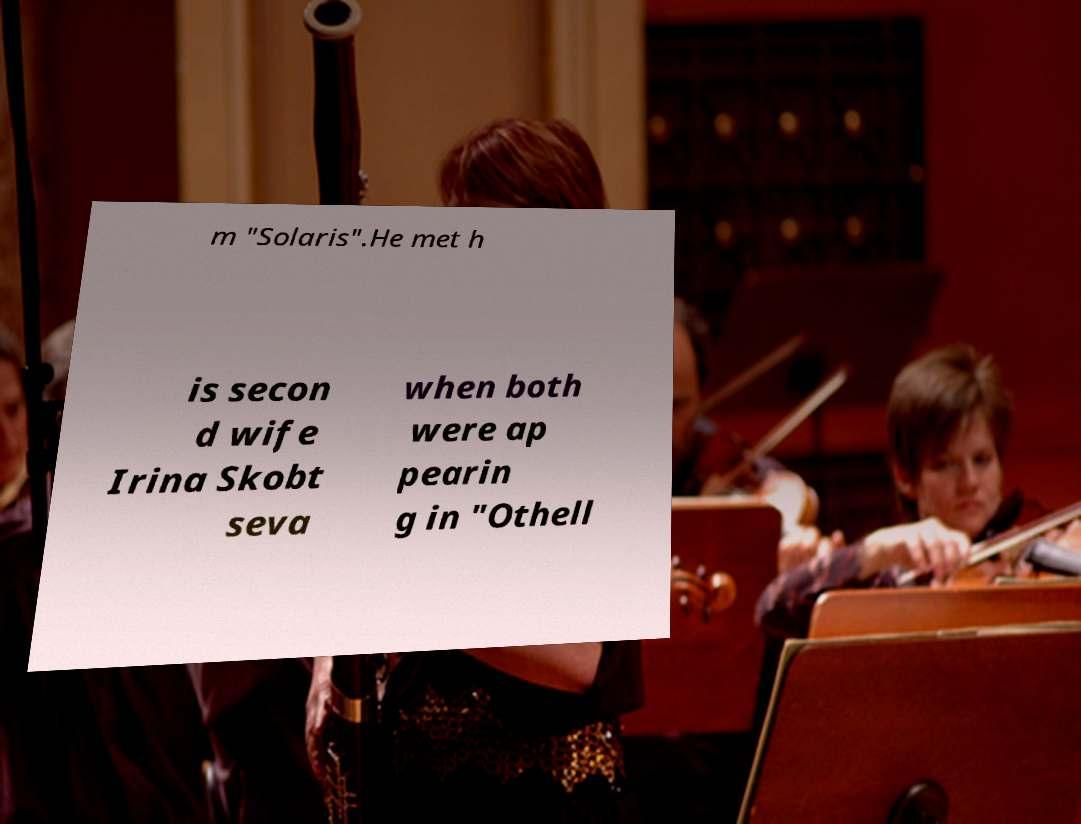Could you extract and type out the text from this image? m "Solaris".He met h is secon d wife Irina Skobt seva when both were ap pearin g in "Othell 